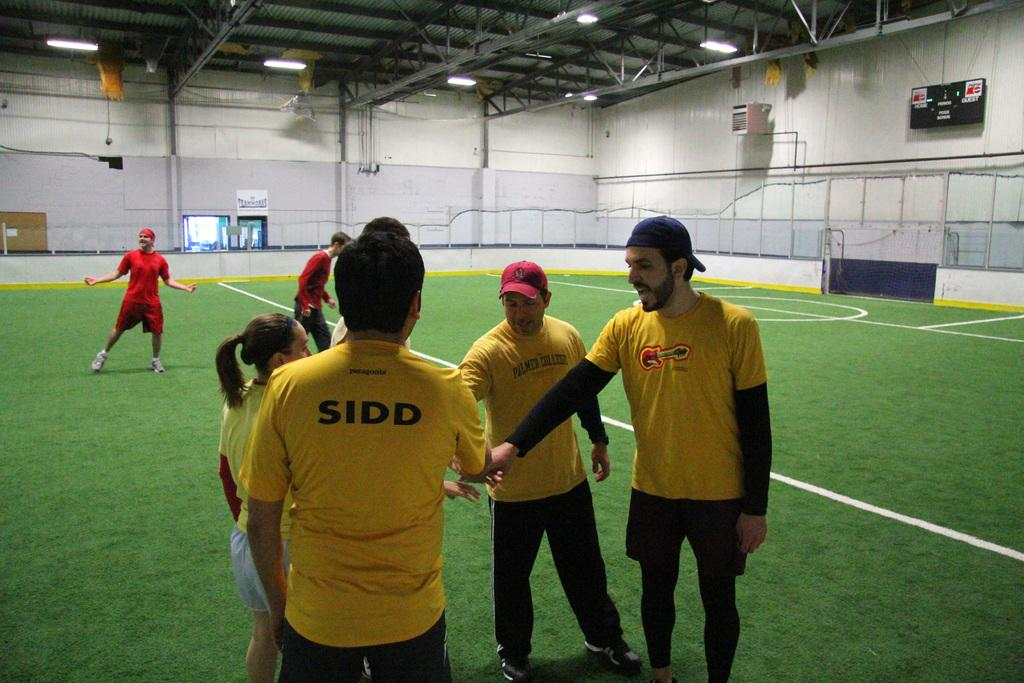What is the surface that the people are standing on in the image? The people are standing on grass in the image. Can you describe the setting of the image? The image appears to depict a complete room. What type of dog can be seen playing with a wristwatch in the image? There is no dog or wristwatch present in the image. 